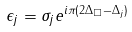<formula> <loc_0><loc_0><loc_500><loc_500>\epsilon _ { j } = \sigma _ { j } e ^ { i \pi ( 2 \Delta _ { \square } - \Delta _ { j } ) }</formula> 